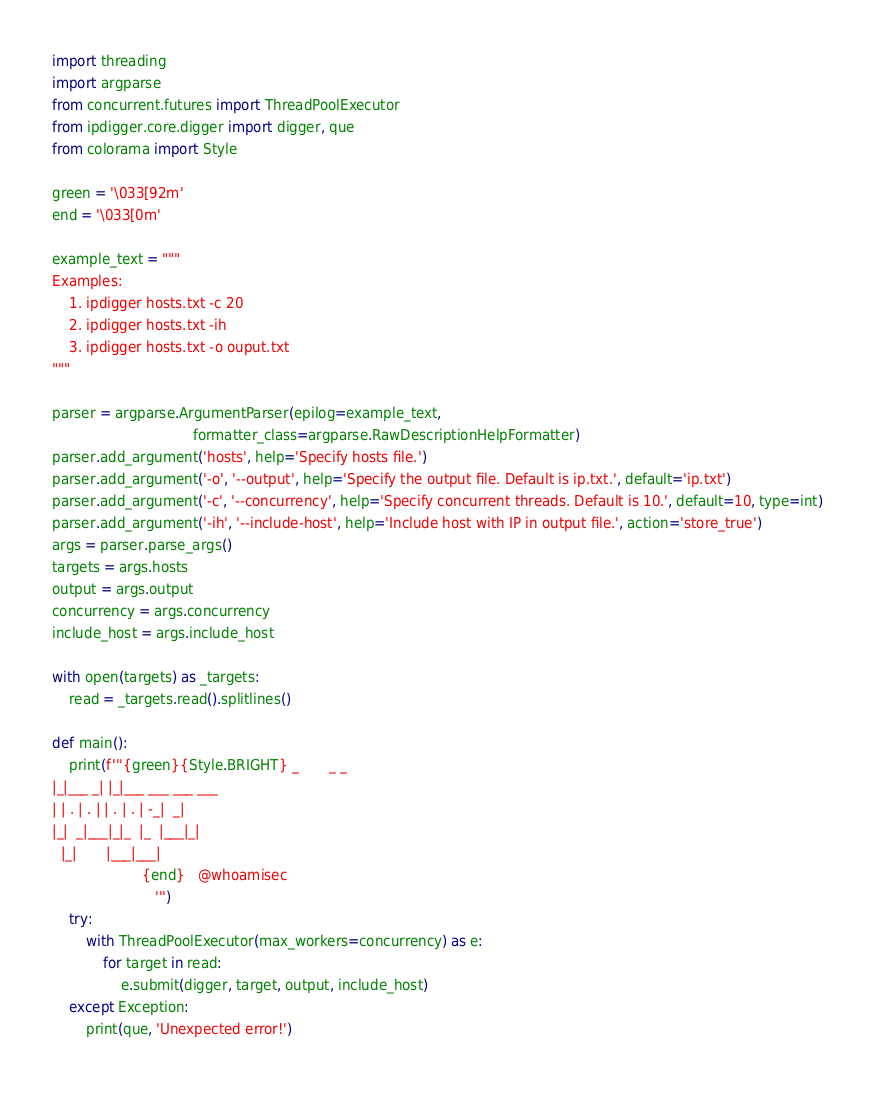<code> <loc_0><loc_0><loc_500><loc_500><_Python_>import threading
import argparse
from concurrent.futures import ThreadPoolExecutor
from ipdigger.core.digger import digger, que
from colorama import Style

green = '\033[92m'
end = '\033[0m'

example_text = """
Examples:
    1. ipdigger hosts.txt -c 20
    2. ipdigger hosts.txt -ih 
    3. ipdigger hosts.txt -o ouput.txt
"""

parser = argparse.ArgumentParser(epilog=example_text,
                                 formatter_class=argparse.RawDescriptionHelpFormatter)
parser.add_argument('hosts', help='Specify hosts file.')
parser.add_argument('-o', '--output', help='Specify the output file. Default is ip.txt.', default='ip.txt')
parser.add_argument('-c', '--concurrency', help='Specify concurrent threads. Default is 10.', default=10, type=int)
parser.add_argument('-ih', '--include-host', help='Include host with IP in output file.', action='store_true')
args = parser.parse_args()
targets = args.hosts
output = args.output
concurrency = args.concurrency
include_host = args.include_host

with open(targets) as _targets:
    read = _targets.read().splitlines()

def main():
    print(f'''{green}{Style.BRIGHT} _       _ _                   
|_|___ _| |_|___ ___ ___ ___   
| | . | . | | . | . | -_|  _|  
|_|  _|___|_|_  |_  |___|_|    
  |_|       |___|___|          
                     {end}   @whoamisec
                        ''')
    try:
        with ThreadPoolExecutor(max_workers=concurrency) as e:
            for target in read:
                e.submit(digger, target, output, include_host)
    except Exception:
        print(que, 'Unexpected error!')</code> 